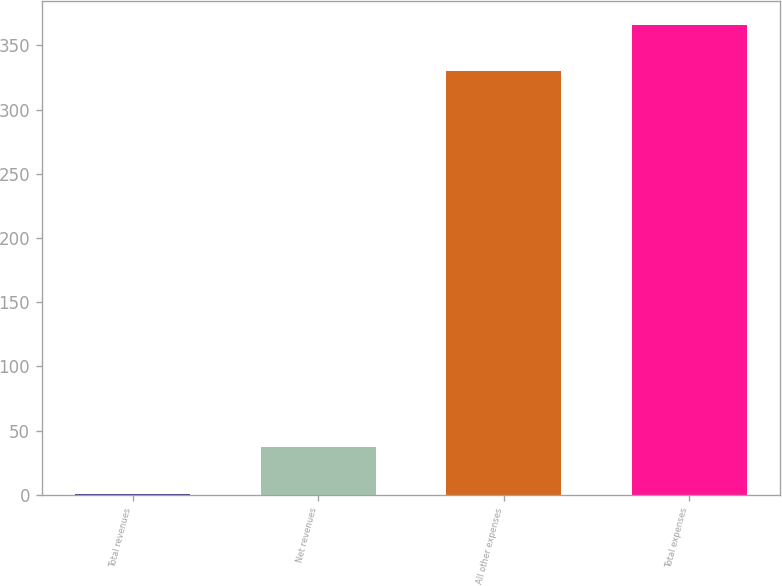Convert chart. <chart><loc_0><loc_0><loc_500><loc_500><bar_chart><fcel>Total revenues<fcel>Net revenues<fcel>All other expenses<fcel>Total expenses<nl><fcel>1<fcel>37.2<fcel>330<fcel>366.2<nl></chart> 